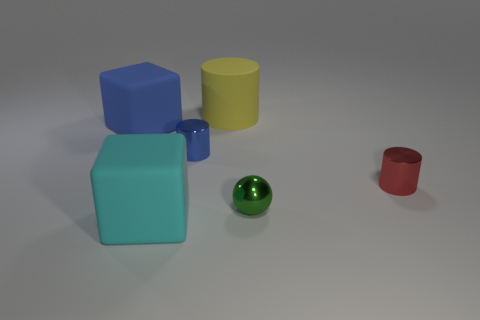What number of other large things have the same material as the big blue thing?
Provide a short and direct response. 2. How many other objects are there of the same size as the blue matte cube?
Provide a succinct answer. 2. Are there any green matte blocks that have the same size as the rubber cylinder?
Give a very brief answer. No. There is a large thing that is behind the large blue thing; is its color the same as the sphere?
Make the answer very short. No. How many objects are either small blue cylinders or red metallic blocks?
Provide a short and direct response. 1. Is the number of yellow things the same as the number of tiny cyan blocks?
Your response must be concise. No. There is a shiny object in front of the red metal object; does it have the same size as the blue cylinder?
Give a very brief answer. Yes. What size is the rubber object that is behind the cyan rubber cube and on the left side of the big yellow object?
Offer a very short reply. Large. How many other objects are there of the same shape as the yellow matte thing?
Your answer should be compact. 2. How many other objects are there of the same material as the cyan cube?
Make the answer very short. 2. 